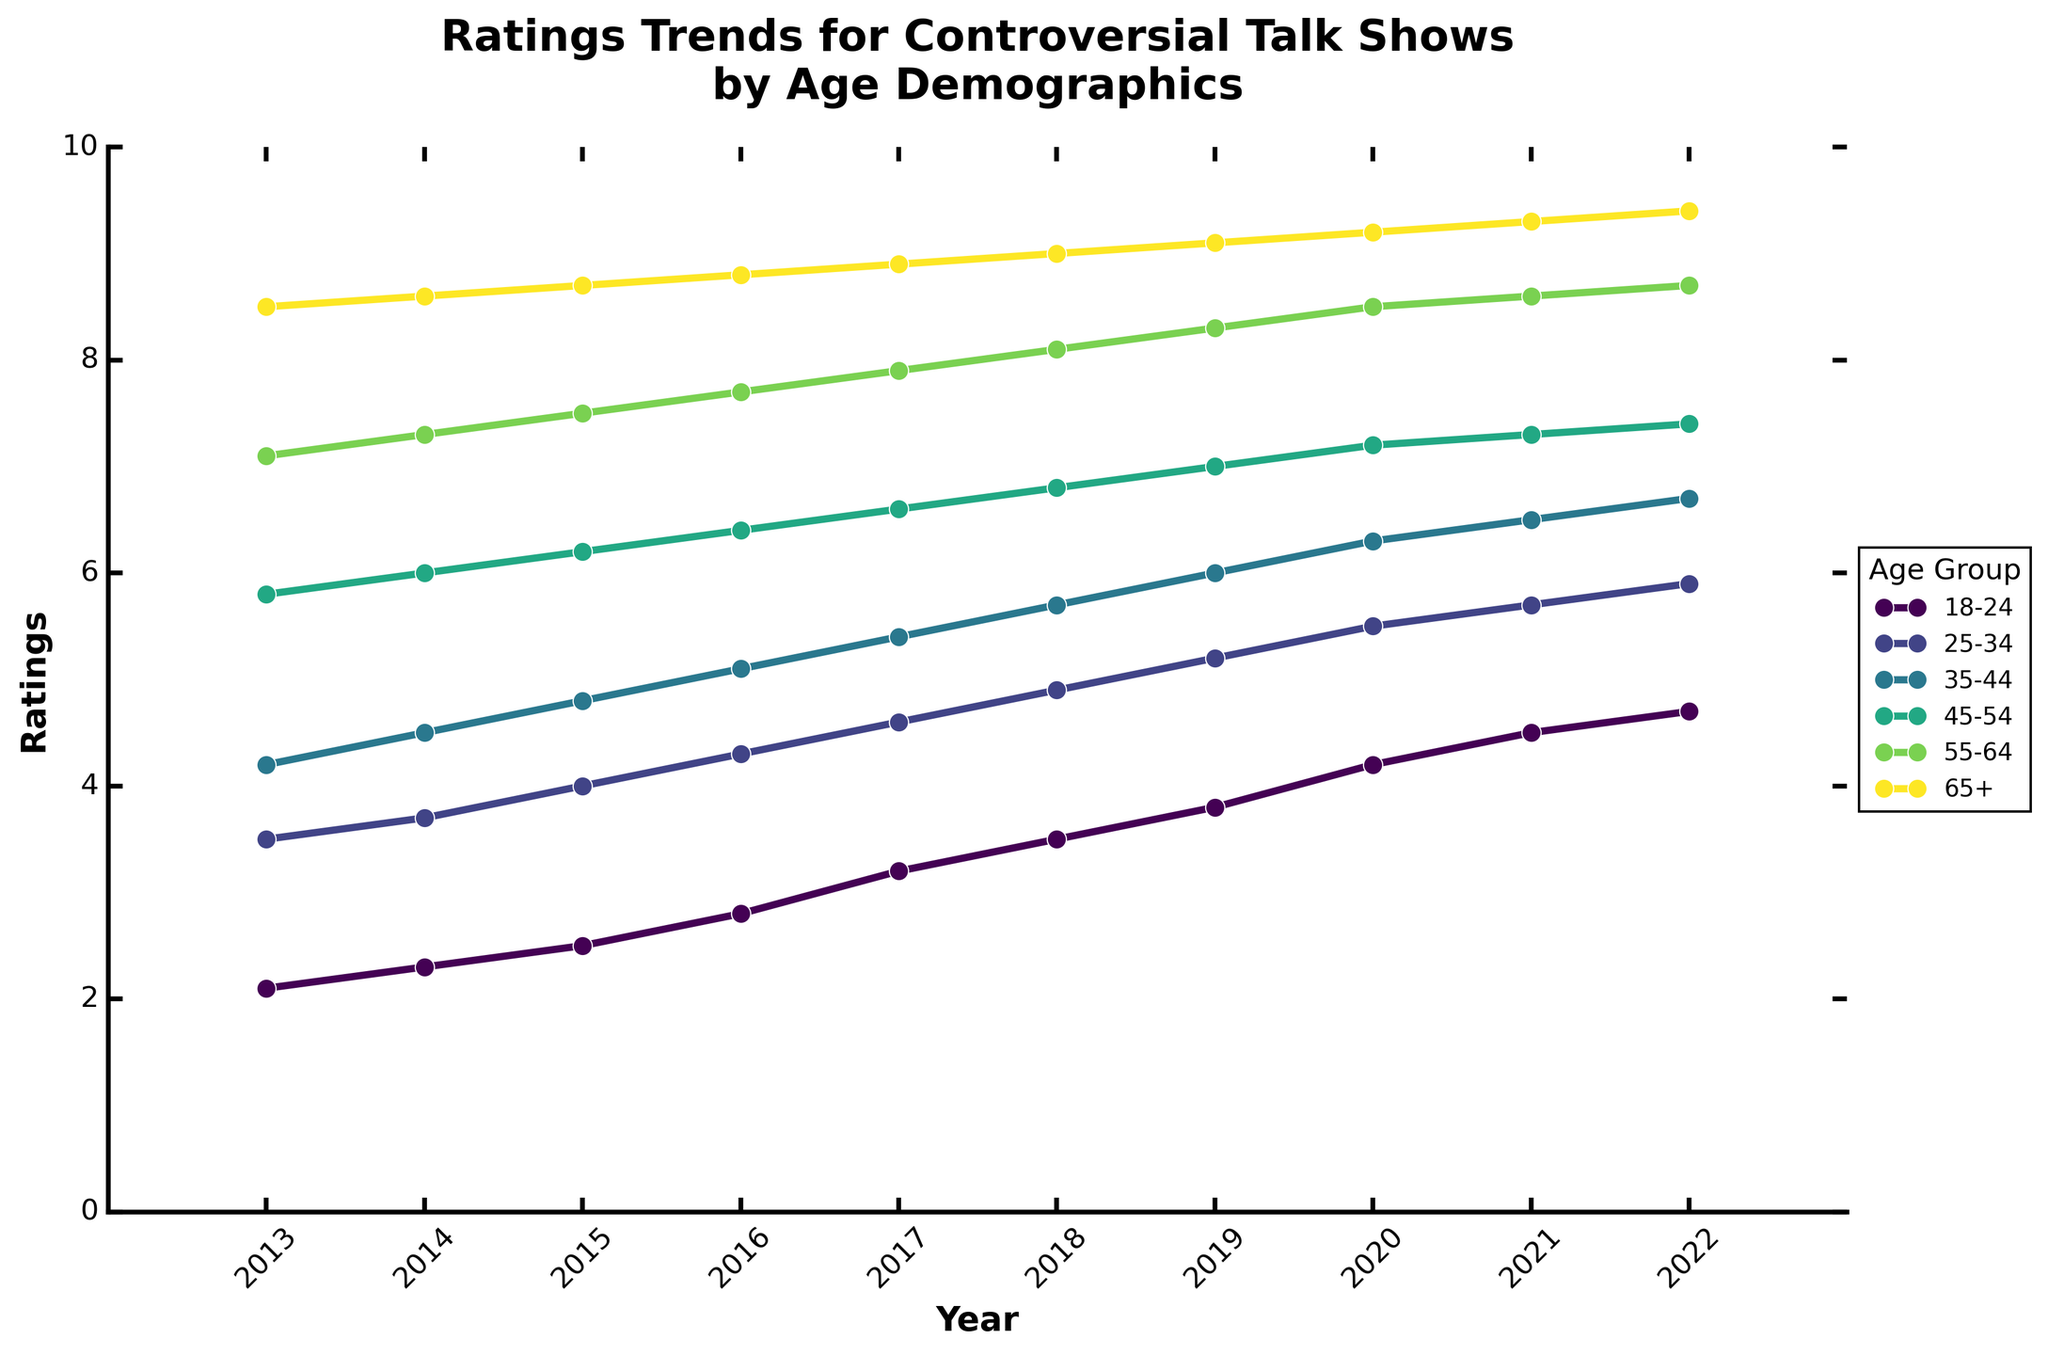Which age group shows the highest rating in 2022? Look at the end of each line in 2022 to find which age group has the highest rating
Answer: 65+ Between which years did the 18-24 age group see the sharpest increase in ratings? Examine the slope of the line representing the 18-24 age group and identify the steepest incline
Answer: 2013 to 2017 How much did the rating for the 45-54 age group increase from 2013 to 2022? Subtract the 2013 rating from the 2022 rating for the 45-54 age group (7.4 - 5.8)
Answer: 1.6 Which two age groups had nearly parallel trends in ratings over the decade? Visually compare the slopes and shapes of the lines for all age groups to find nearly parallel lines
Answer: 18-24 and 25-34 How does the trend for the 65+ age group compare to the trend for the 18-24 age group? Compare the two lines, noting the slope and starting/ending points
Answer: 65+ consistently higher What is the average rating for the 35-44 age group between 2013 and 2022? Add up all the ratings for the 35-44 age group from 2013 to 2022 and divide by the number of years (4.2+4.5+4.8+5.1+5.4+5.7+6+6.3+6.5+6.7)/10
Answer: 5.52 In which year did the 55-64 age group have its first rating of 8 or higher? Find the first rating value of 8 or above for the 55-64 age group in the line from 2013 to 2022
Answer: 2018 What is the difference in ratings between the youngest (18-24) and the oldest (65+) age groups in 2022? Subtract the rating of 18-24 from the rating of 65+ in 2022 (9.4 - 4.7)
Answer: 4.7 Which age group shows the most consistent increase in ratings over the decade? Look for the line with the most uniform slope and least variation in year-to-year changes
Answer: 65+ During which year did the 25-34 age group surpass the 18-24 age group in ratings? Identify the first year when the line for 25-34 is consistently above 18-24
Answer: 2014 